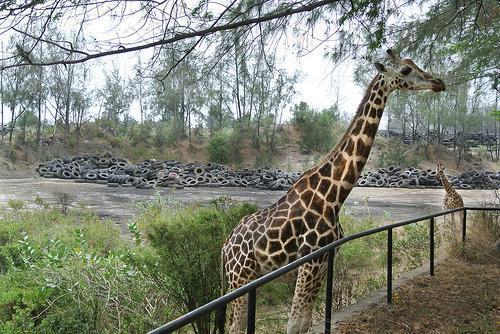How many giraffes are there?
Give a very brief answer. 2. How many giraffes are in the picture?
Give a very brief answer. 2. 